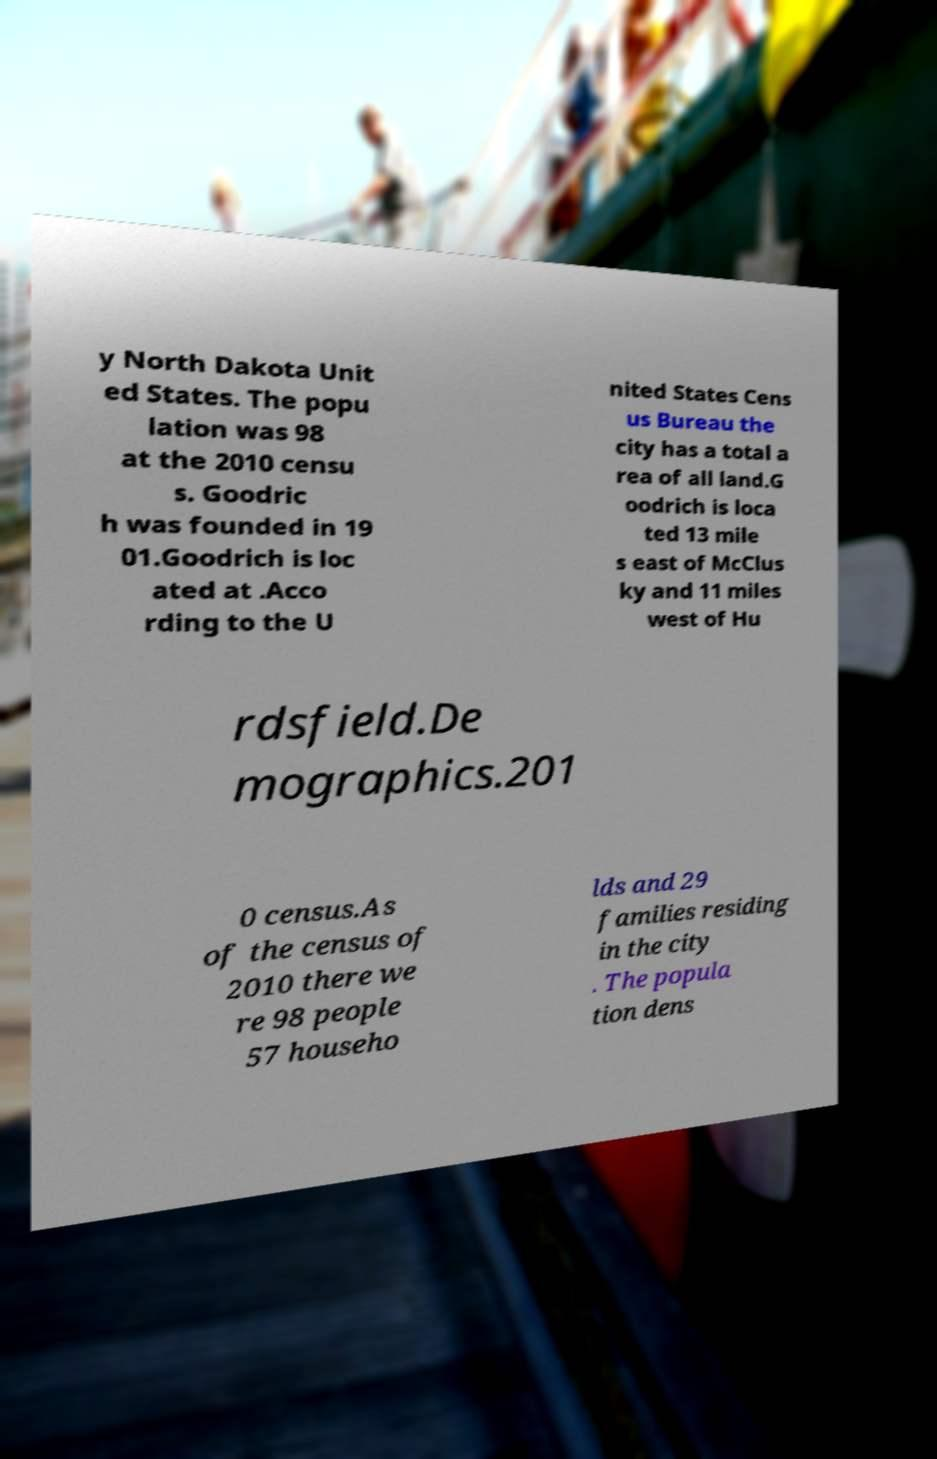Please read and relay the text visible in this image. What does it say? y North Dakota Unit ed States. The popu lation was 98 at the 2010 censu s. Goodric h was founded in 19 01.Goodrich is loc ated at .Acco rding to the U nited States Cens us Bureau the city has a total a rea of all land.G oodrich is loca ted 13 mile s east of McClus ky and 11 miles west of Hu rdsfield.De mographics.201 0 census.As of the census of 2010 there we re 98 people 57 househo lds and 29 families residing in the city . The popula tion dens 